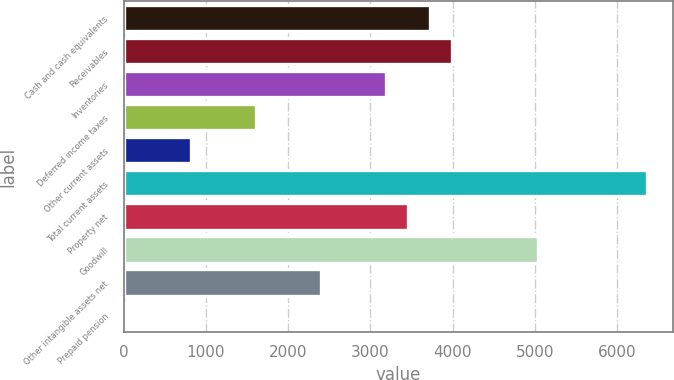<chart> <loc_0><loc_0><loc_500><loc_500><bar_chart><fcel>Cash and cash equivalents<fcel>Receivables<fcel>Inventories<fcel>Deferred income taxes<fcel>Other current assets<fcel>Total current assets<fcel>Property net<fcel>Goodwill<fcel>Other intangible assets net<fcel>Prepaid pension<nl><fcel>3721.8<fcel>3985.45<fcel>3194.5<fcel>1612.6<fcel>821.65<fcel>6358.3<fcel>3458.15<fcel>5040.05<fcel>2403.55<fcel>30.7<nl></chart> 